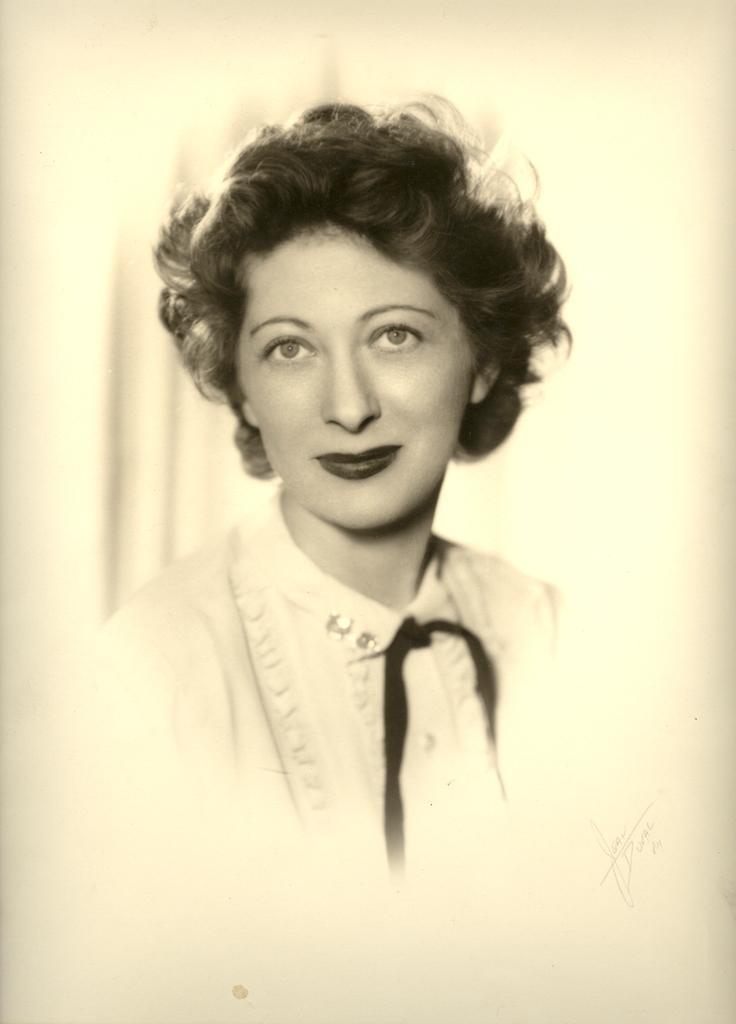How would you summarize this image in a sentence or two? In the image there is a picture of a woman, she is very beautiful and she is wearing a collar neck dress. 